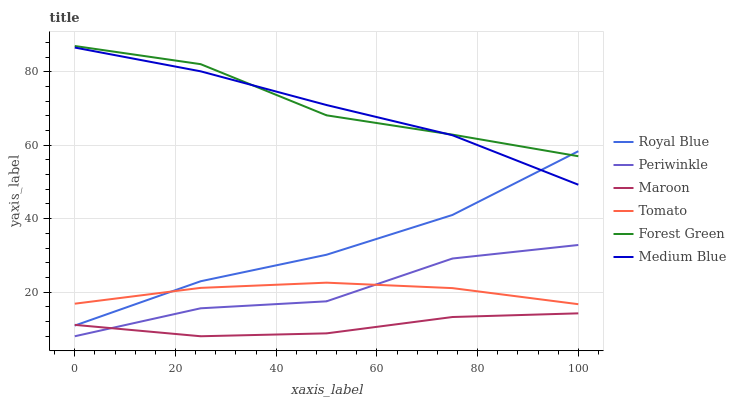Does Maroon have the minimum area under the curve?
Answer yes or no. Yes. Does Forest Green have the maximum area under the curve?
Answer yes or no. Yes. Does Medium Blue have the minimum area under the curve?
Answer yes or no. No. Does Medium Blue have the maximum area under the curve?
Answer yes or no. No. Is Tomato the smoothest?
Answer yes or no. Yes. Is Periwinkle the roughest?
Answer yes or no. Yes. Is Medium Blue the smoothest?
Answer yes or no. No. Is Medium Blue the roughest?
Answer yes or no. No. Does Maroon have the lowest value?
Answer yes or no. Yes. Does Medium Blue have the lowest value?
Answer yes or no. No. Does Forest Green have the highest value?
Answer yes or no. Yes. Does Medium Blue have the highest value?
Answer yes or no. No. Is Periwinkle less than Royal Blue?
Answer yes or no. Yes. Is Forest Green greater than Tomato?
Answer yes or no. Yes. Does Forest Green intersect Medium Blue?
Answer yes or no. Yes. Is Forest Green less than Medium Blue?
Answer yes or no. No. Is Forest Green greater than Medium Blue?
Answer yes or no. No. Does Periwinkle intersect Royal Blue?
Answer yes or no. No. 